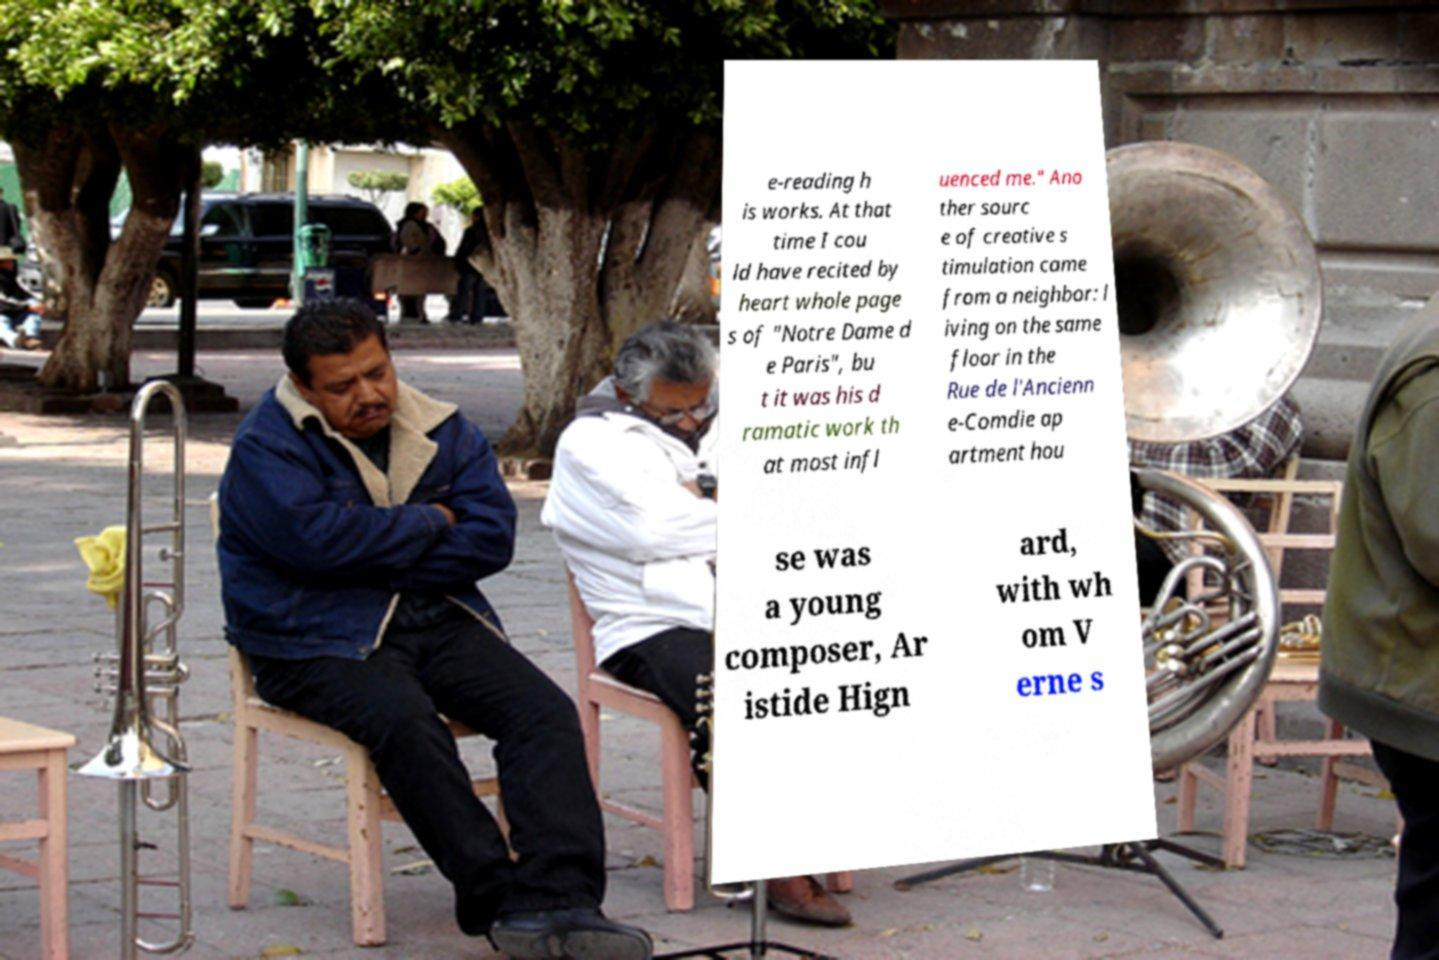Can you read and provide the text displayed in the image?This photo seems to have some interesting text. Can you extract and type it out for me? e-reading h is works. At that time I cou ld have recited by heart whole page s of "Notre Dame d e Paris", bu t it was his d ramatic work th at most infl uenced me." Ano ther sourc e of creative s timulation came from a neighbor: l iving on the same floor in the Rue de l'Ancienn e-Comdie ap artment hou se was a young composer, Ar istide Hign ard, with wh om V erne s 